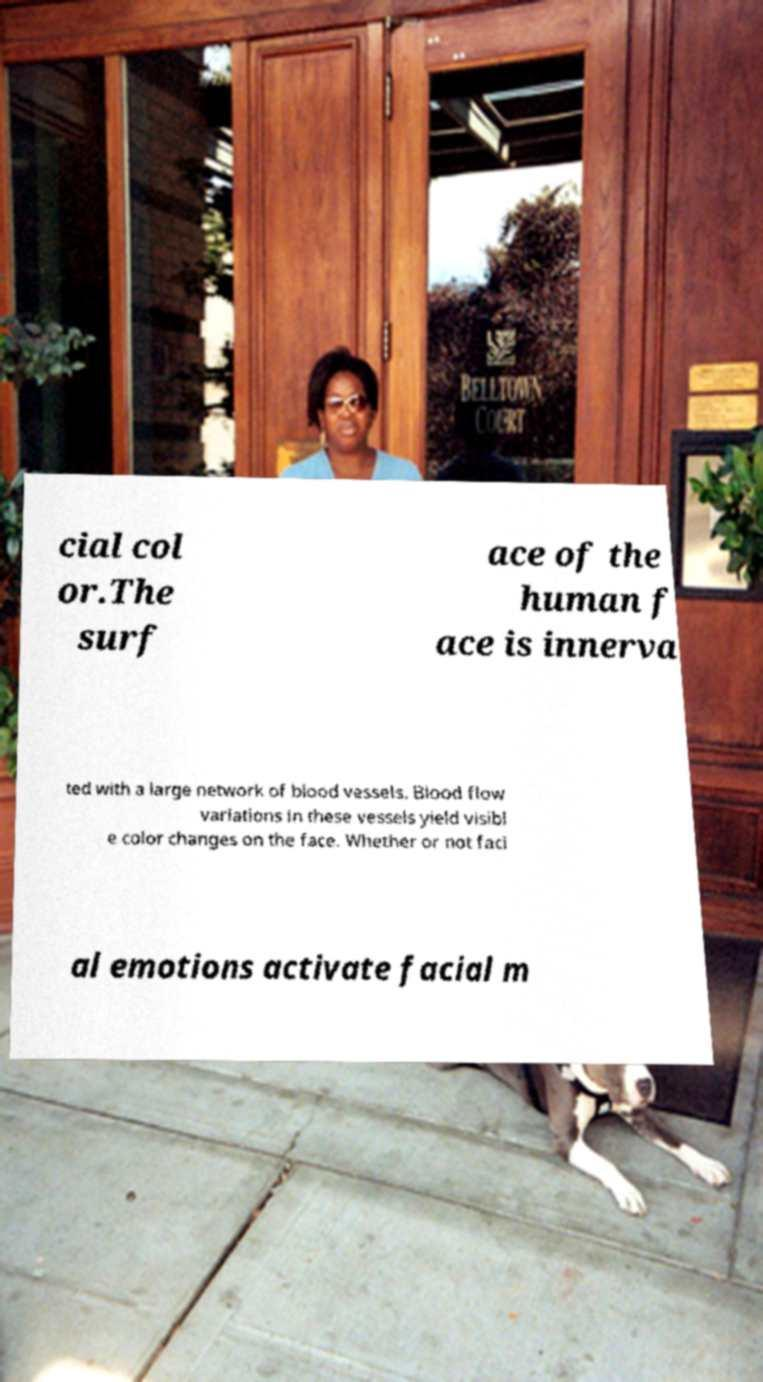I need the written content from this picture converted into text. Can you do that? cial col or.The surf ace of the human f ace is innerva ted with a large network of blood vessels. Blood flow variations in these vessels yield visibl e color changes on the face. Whether or not faci al emotions activate facial m 